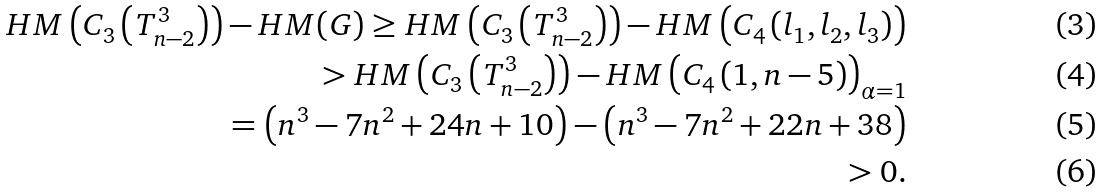Convert formula to latex. <formula><loc_0><loc_0><loc_500><loc_500>H M \left ( C _ { 3 } \left ( T ^ { 3 } _ { n - 2 } \right ) \right ) - H M ( G ) \geq H M \left ( C _ { 3 } \left ( T ^ { 3 } _ { n - 2 } \right ) \right ) - H M \left ( C _ { 4 } \left ( l _ { 1 } , l _ { 2 } , l _ { 3 } \right ) \right ) \\ > H M \left ( C _ { 3 } \left ( T ^ { 3 } _ { n - 2 } \right ) \right ) - H M \left ( C _ { 4 } \left ( 1 , n - 5 \right ) \right ) _ { \alpha = 1 } \\ = \left ( n ^ { 3 } - 7 n ^ { 2 } + 2 4 n + 1 0 \right ) - \left ( n ^ { 3 } - 7 n ^ { 2 } + 2 2 n + 3 8 \right ) \\ > 0 .</formula> 